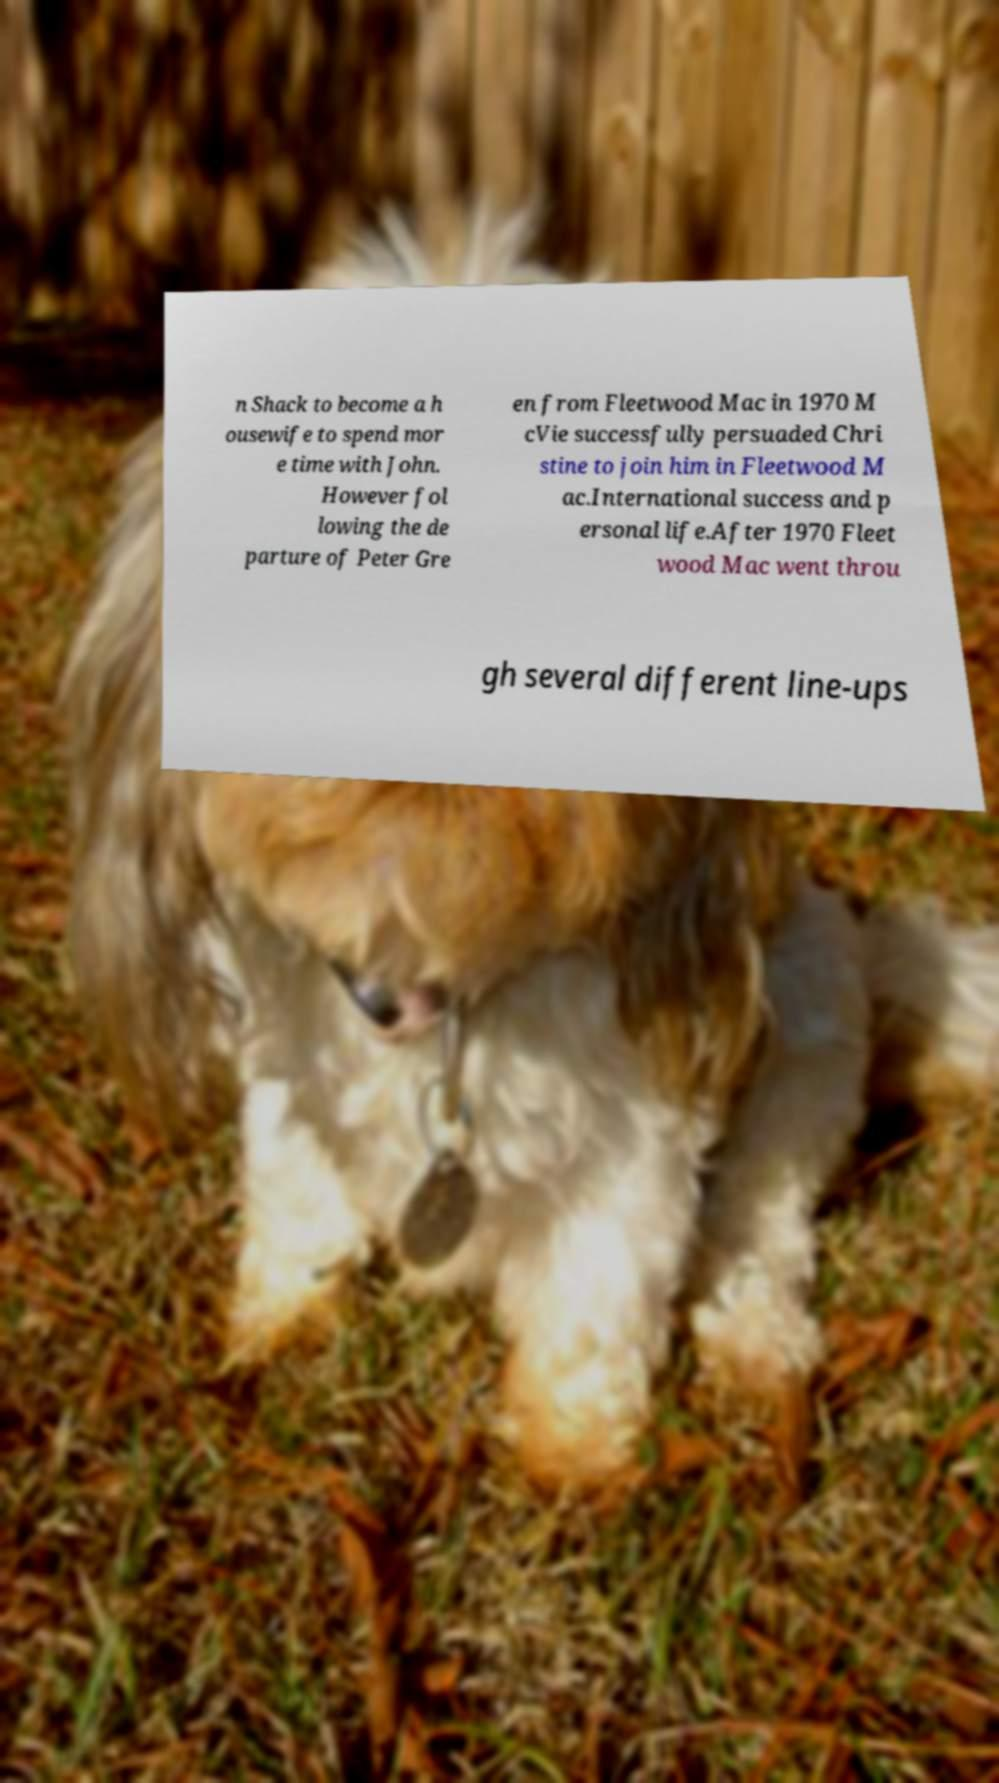Could you assist in decoding the text presented in this image and type it out clearly? n Shack to become a h ousewife to spend mor e time with John. However fol lowing the de parture of Peter Gre en from Fleetwood Mac in 1970 M cVie successfully persuaded Chri stine to join him in Fleetwood M ac.International success and p ersonal life.After 1970 Fleet wood Mac went throu gh several different line-ups 